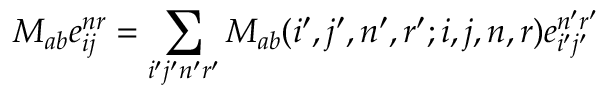Convert formula to latex. <formula><loc_0><loc_0><loc_500><loc_500>M _ { a b } e _ { i j } ^ { n r } = \sum _ { i ^ { \prime } j ^ { \prime } n ^ { \prime } r ^ { \prime } } M _ { a b } ( i ^ { \prime } , j ^ { \prime } , n ^ { \prime } , r ^ { \prime } ; i , j , n , r ) e _ { i ^ { \prime } j ^ { \prime } } ^ { n ^ { \prime } r ^ { \prime } }</formula> 